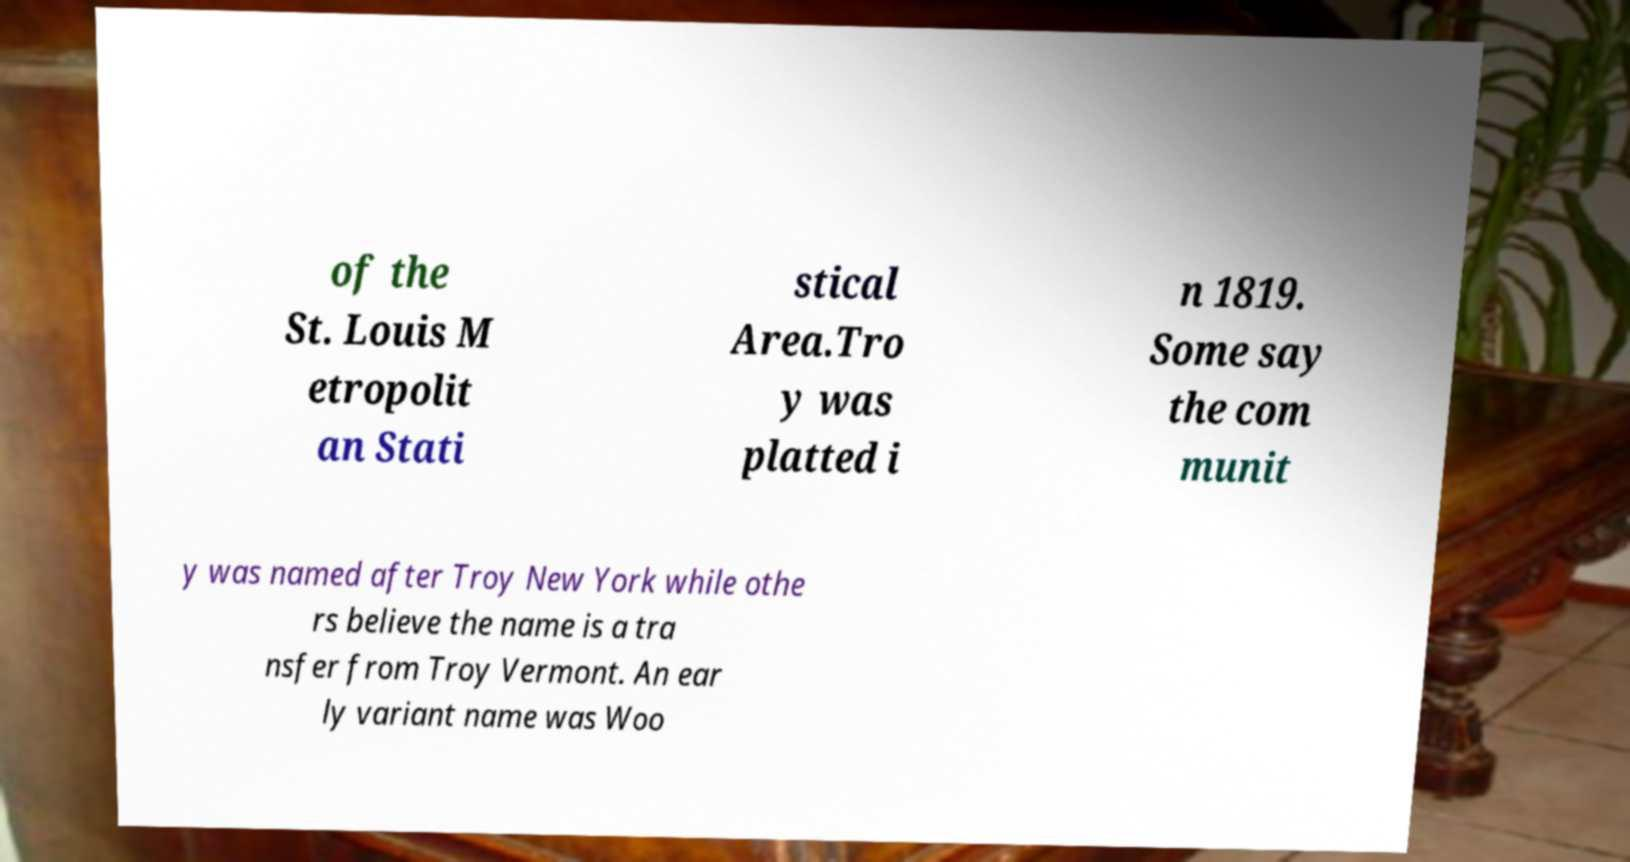Can you read and provide the text displayed in the image?This photo seems to have some interesting text. Can you extract and type it out for me? of the St. Louis M etropolit an Stati stical Area.Tro y was platted i n 1819. Some say the com munit y was named after Troy New York while othe rs believe the name is a tra nsfer from Troy Vermont. An ear ly variant name was Woo 